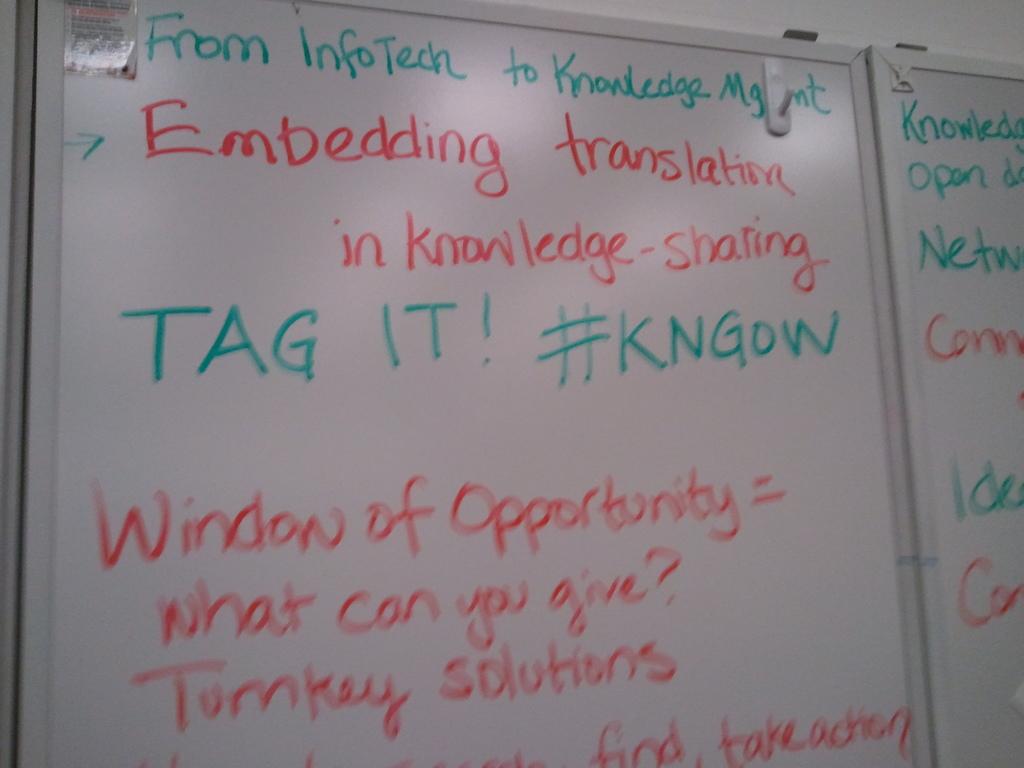What is the topic of these notes?
Provide a succinct answer. Unanswerable. What is the hashtag?
Offer a very short reply. #kngow. 